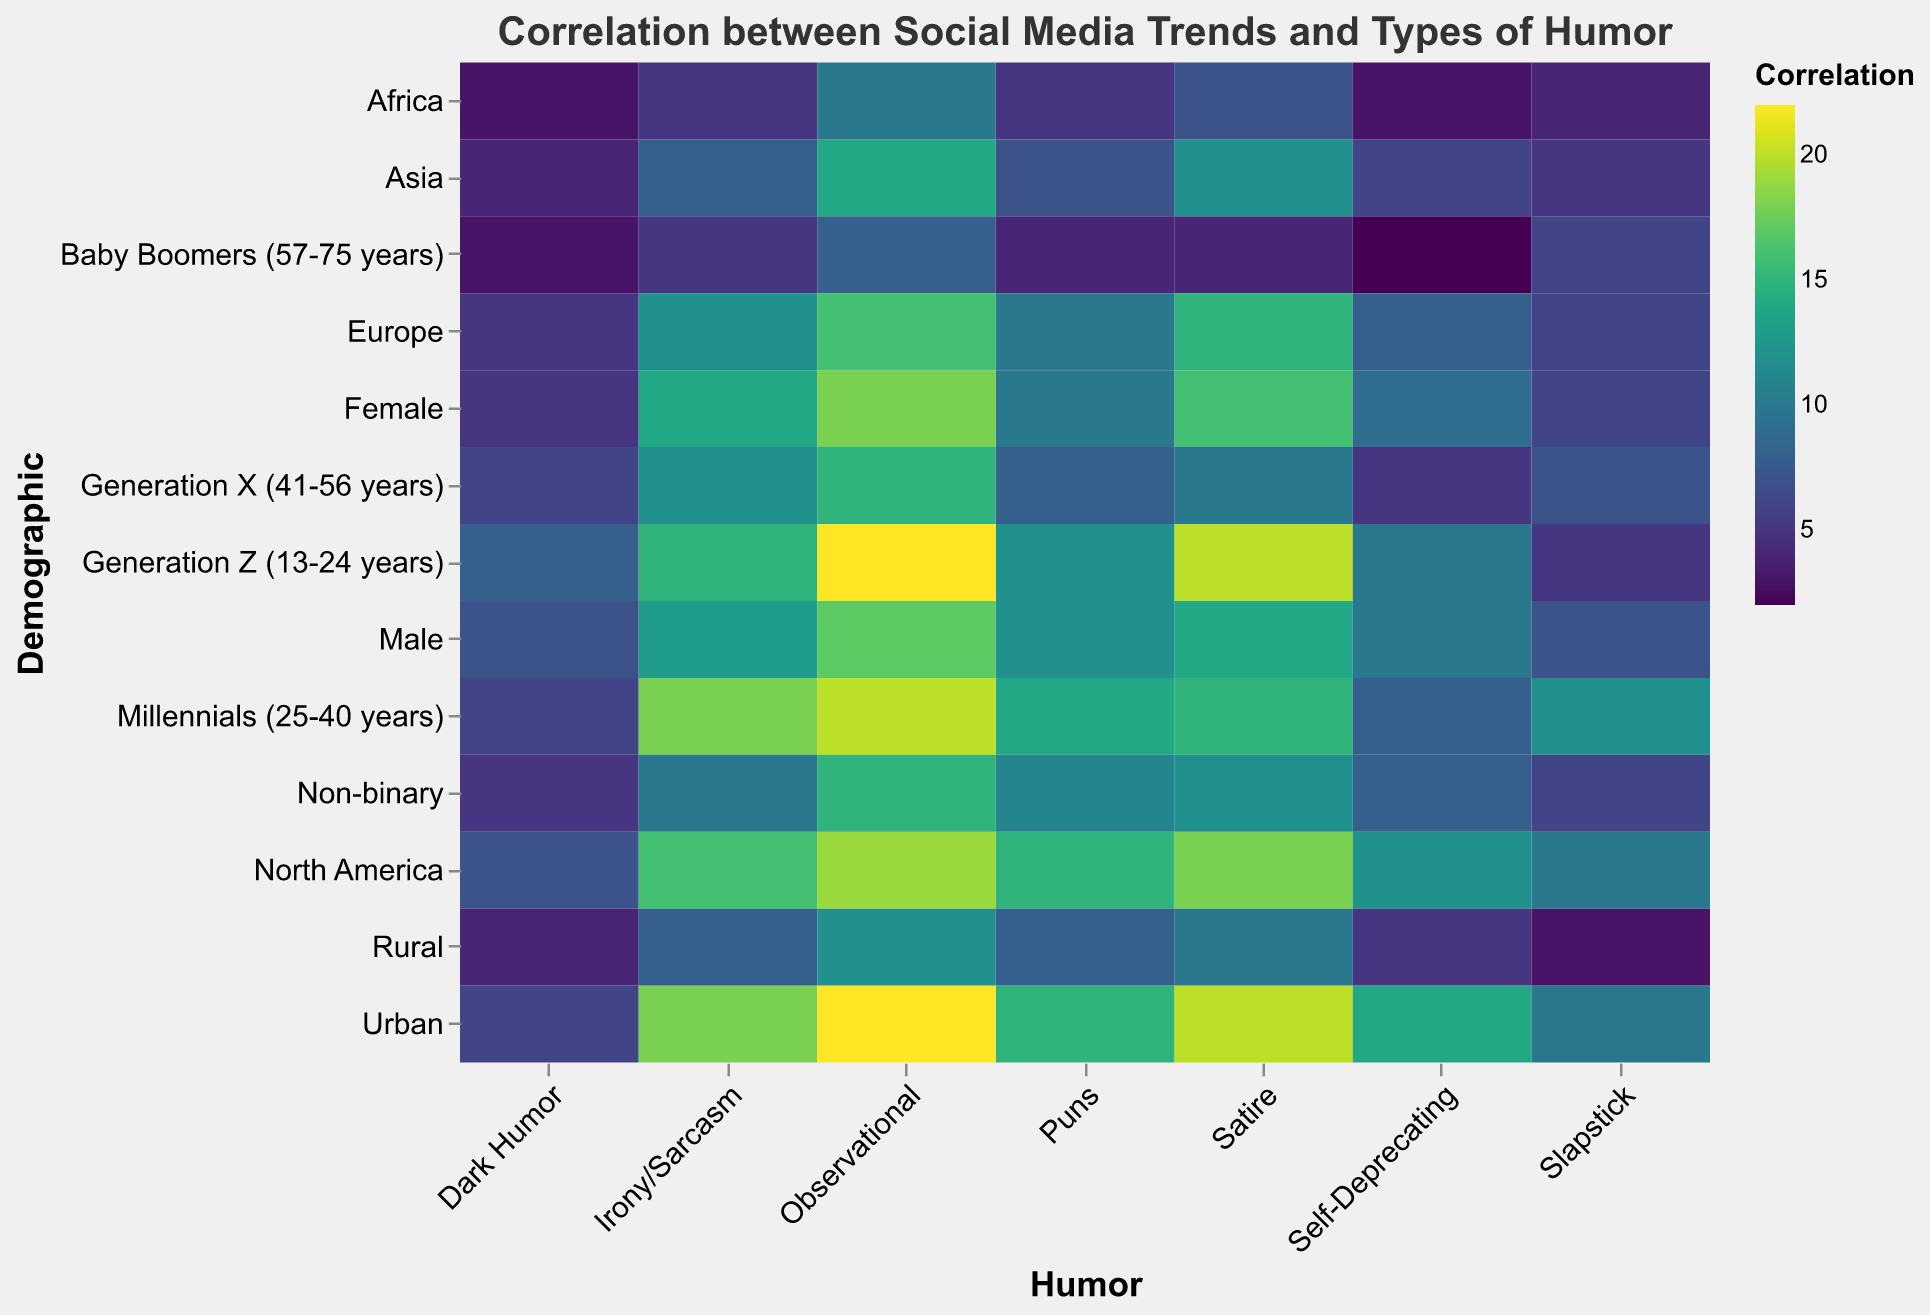What's the title of the figure? The title is located at the top of the heatmap. It provides a quick overview of what the heatmap represents. In this case, it reads "Correlation between Social Media Trends and Types of Humor".
Answer: Correlation between Social Media Trends and Types of Humor How many types of humor are included in the figure? To find the types of humor, look at the labels on the x-axis. They are Irony/Sarcasm, Satire, Self-Deprecating, Slapstick, Puns, Observational, and Dark Humor. Counting them gives us a total.
Answer: 7 Which demographic shows the highest preference for Observational humor? To determine this, find the highest value in the column labeled 'Observational' on the x-axis. The Urban demographic shows a value of 22, which is the highest.
Answer: Urban Compare the preference for Dark Humor between Generation Z and Baby Boomers. Look at the Dark Humor column and locate the values for Generation Z and Baby Boomers. Generation Z has a value of 8, and Baby Boomers have a value of 3.
Answer: Generation Z prefers Dark Humor more than Baby Boomers Which demographic has the lowest value for Satire? To answer this, look for the lowest value in the Satire column. The lowest value is 4, corresponding to Baby Boomers.
Answer: Baby Boomers What is the sum of values for Slapstick humor across all demographics? Add up all the values under the Slapstick column. That gives us 5 + 12 + 7 + 6 + 10 + 6 + 5 + 4 + 6 + 7 + 6 + 10 + 3. Summing these, we get 87.
Answer: 87 What demographic prefers Irony/Sarcasm the most? Look for the highest value in the Irony/Sarcasm column. The value of 18 is highest for the Urban demographic.
Answer: Urban Which humor type does the Female demographic prefer the least? In the Female row, find the lowest value. The lowest value is 5, which corresponds to Dark Humor.
Answer: Dark Humor Between North America and Europe, which region has a higher preference for Puns? Compare the values in the Puns column for North America and Europe. North America has a value of 15, and Europe has a value of 10.
Answer: North America 